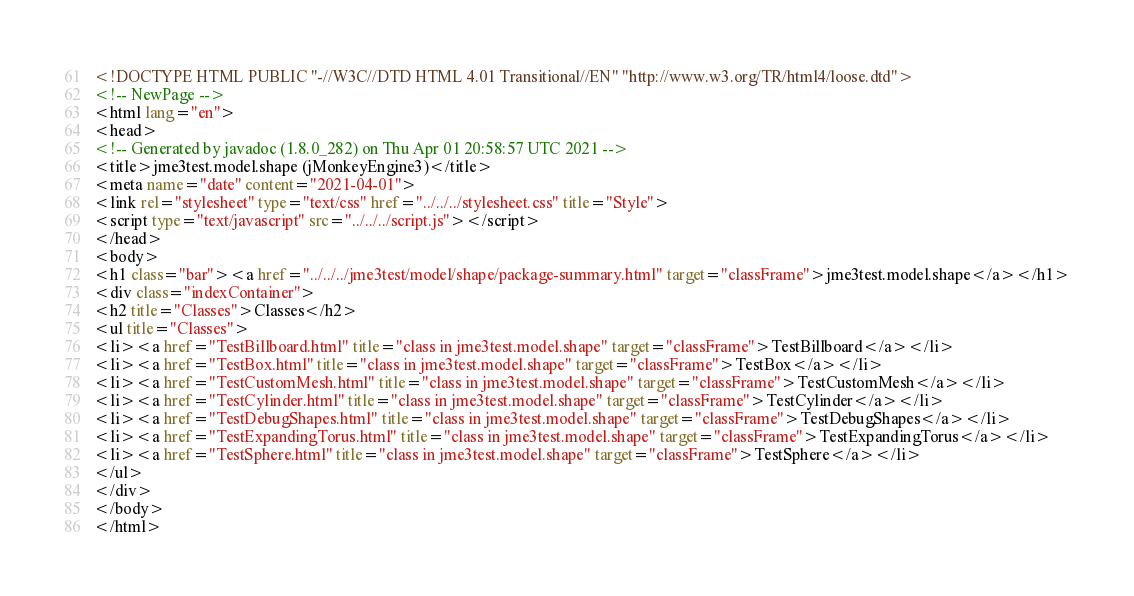Convert code to text. <code><loc_0><loc_0><loc_500><loc_500><_HTML_><!DOCTYPE HTML PUBLIC "-//W3C//DTD HTML 4.01 Transitional//EN" "http://www.w3.org/TR/html4/loose.dtd">
<!-- NewPage -->
<html lang="en">
<head>
<!-- Generated by javadoc (1.8.0_282) on Thu Apr 01 20:58:57 UTC 2021 -->
<title>jme3test.model.shape (jMonkeyEngine3)</title>
<meta name="date" content="2021-04-01">
<link rel="stylesheet" type="text/css" href="../../../stylesheet.css" title="Style">
<script type="text/javascript" src="../../../script.js"></script>
</head>
<body>
<h1 class="bar"><a href="../../../jme3test/model/shape/package-summary.html" target="classFrame">jme3test.model.shape</a></h1>
<div class="indexContainer">
<h2 title="Classes">Classes</h2>
<ul title="Classes">
<li><a href="TestBillboard.html" title="class in jme3test.model.shape" target="classFrame">TestBillboard</a></li>
<li><a href="TestBox.html" title="class in jme3test.model.shape" target="classFrame">TestBox</a></li>
<li><a href="TestCustomMesh.html" title="class in jme3test.model.shape" target="classFrame">TestCustomMesh</a></li>
<li><a href="TestCylinder.html" title="class in jme3test.model.shape" target="classFrame">TestCylinder</a></li>
<li><a href="TestDebugShapes.html" title="class in jme3test.model.shape" target="classFrame">TestDebugShapes</a></li>
<li><a href="TestExpandingTorus.html" title="class in jme3test.model.shape" target="classFrame">TestExpandingTorus</a></li>
<li><a href="TestSphere.html" title="class in jme3test.model.shape" target="classFrame">TestSphere</a></li>
</ul>
</div>
</body>
</html>
</code> 